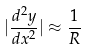Convert formula to latex. <formula><loc_0><loc_0><loc_500><loc_500>| \frac { d ^ { 2 } y } { d x ^ { 2 } } | \approx \frac { 1 } { R }</formula> 